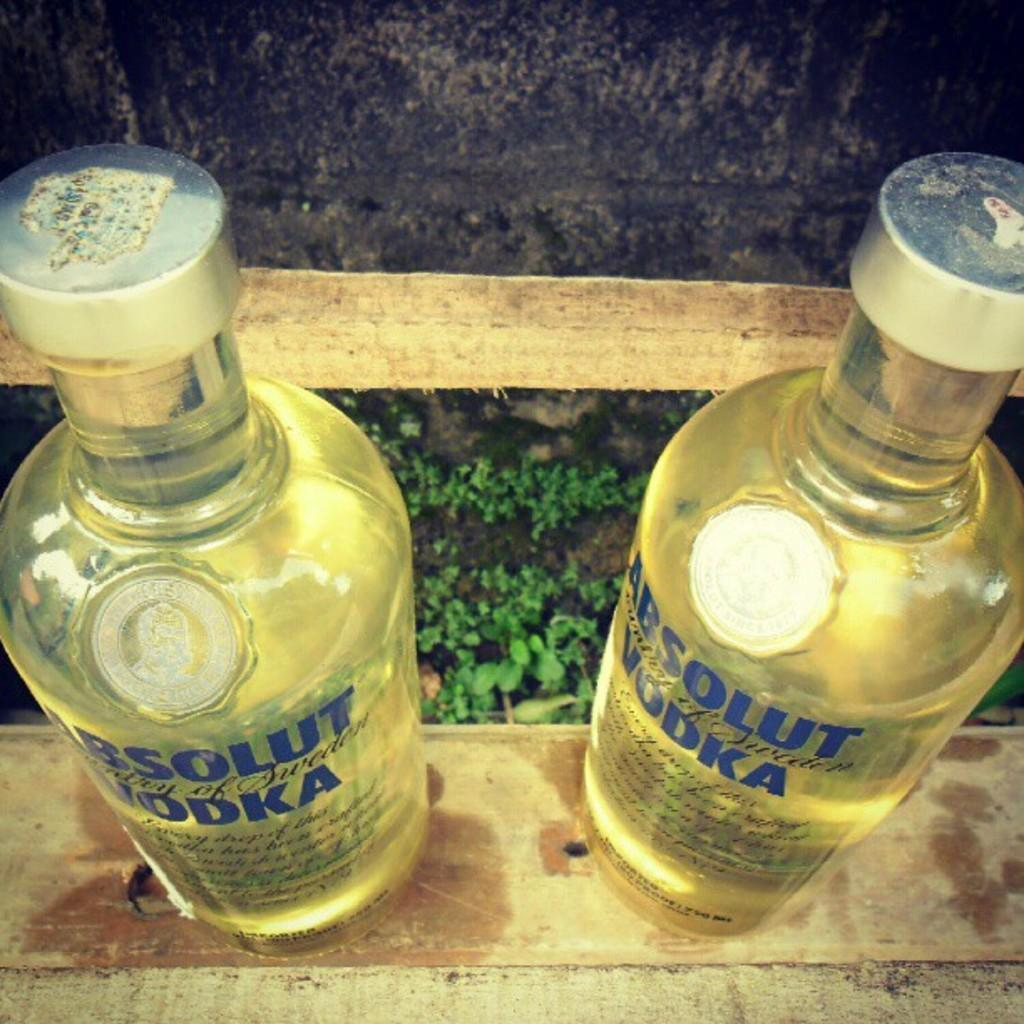<image>
Present a compact description of the photo's key features. Two bottles of Absolute Vodka are next to each other. 